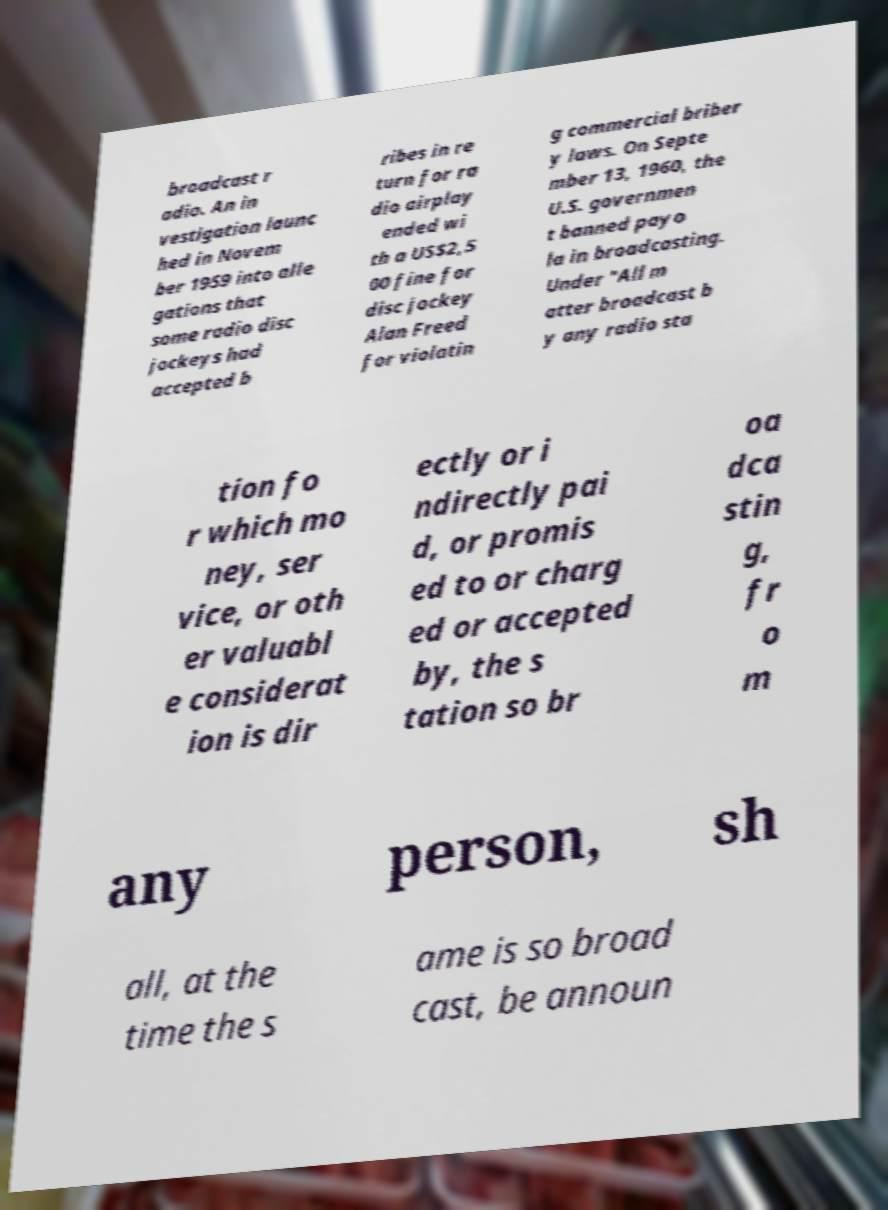What messages or text are displayed in this image? I need them in a readable, typed format. broadcast r adio. An in vestigation launc hed in Novem ber 1959 into alle gations that some radio disc jockeys had accepted b ribes in re turn for ra dio airplay ended wi th a US$2,5 00 fine for disc jockey Alan Freed for violatin g commercial briber y laws. On Septe mber 13, 1960, the U.S. governmen t banned payo la in broadcasting. Under "All m atter broadcast b y any radio sta tion fo r which mo ney, ser vice, or oth er valuabl e considerat ion is dir ectly or i ndirectly pai d, or promis ed to or charg ed or accepted by, the s tation so br oa dca stin g, fr o m any person, sh all, at the time the s ame is so broad cast, be announ 